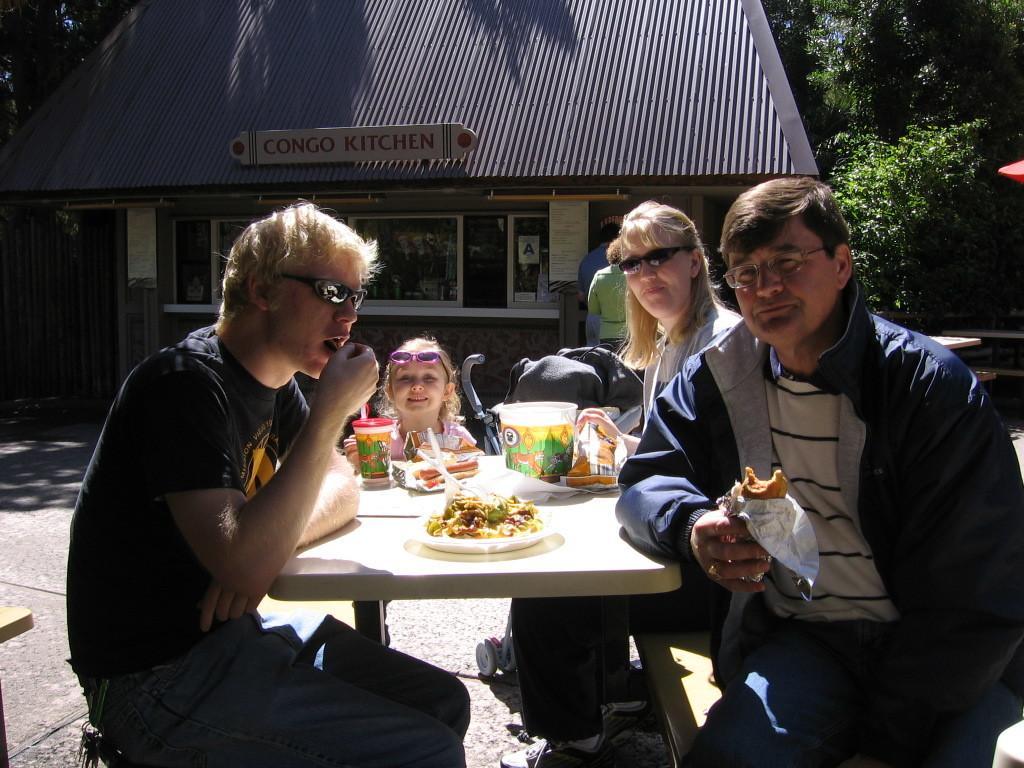Can you describe this image briefly? In this picture we can see a group of people sitting on benches and in front of them on table we can see food items, glass, packs and in the background we can see a house with windows, trees, name board. 